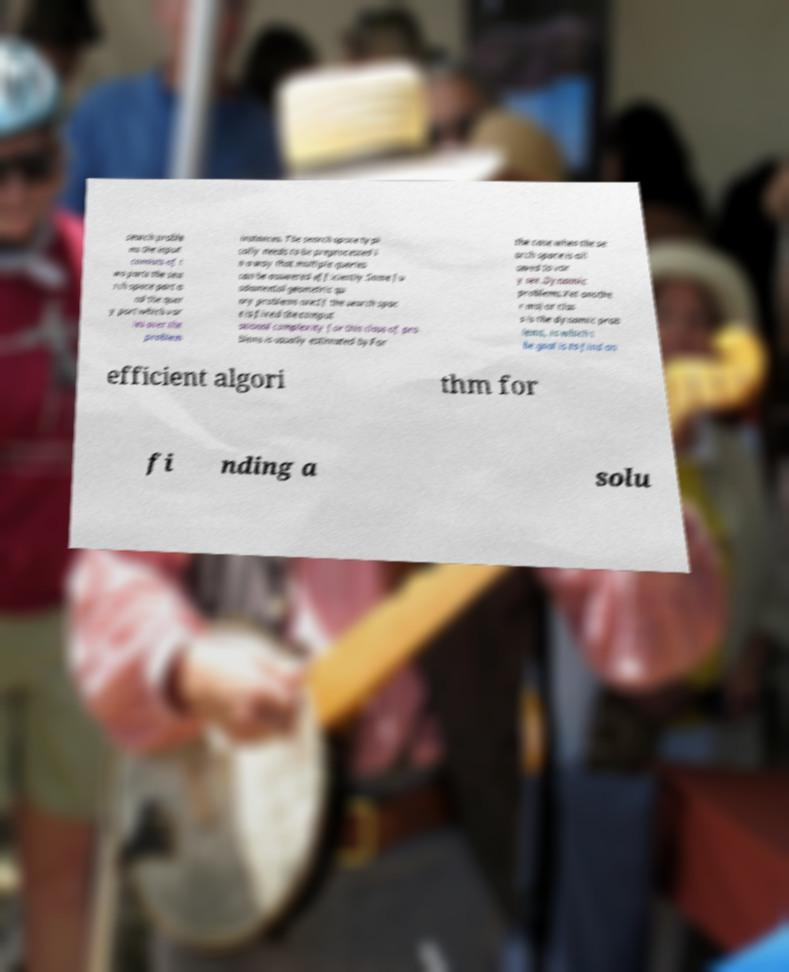Can you accurately transcribe the text from the provided image for me? search proble ms the input consists of t wo parts the sea rch space part a nd the quer y part which var ies over the problem instances. The search space typi cally needs to be preprocessed i n a way that multiple queries can be answered efficiently.Some fu ndamental geometric qu ery problems are:If the search spac e is fixed the comput ational complexity for this class of pro blems is usually estimated byFor the case when the se arch space is all owed to var y see .Dynamic problems.Yet anothe r major clas s is the dynamic prob lems, in which t he goal is to find an efficient algori thm for fi nding a solu 